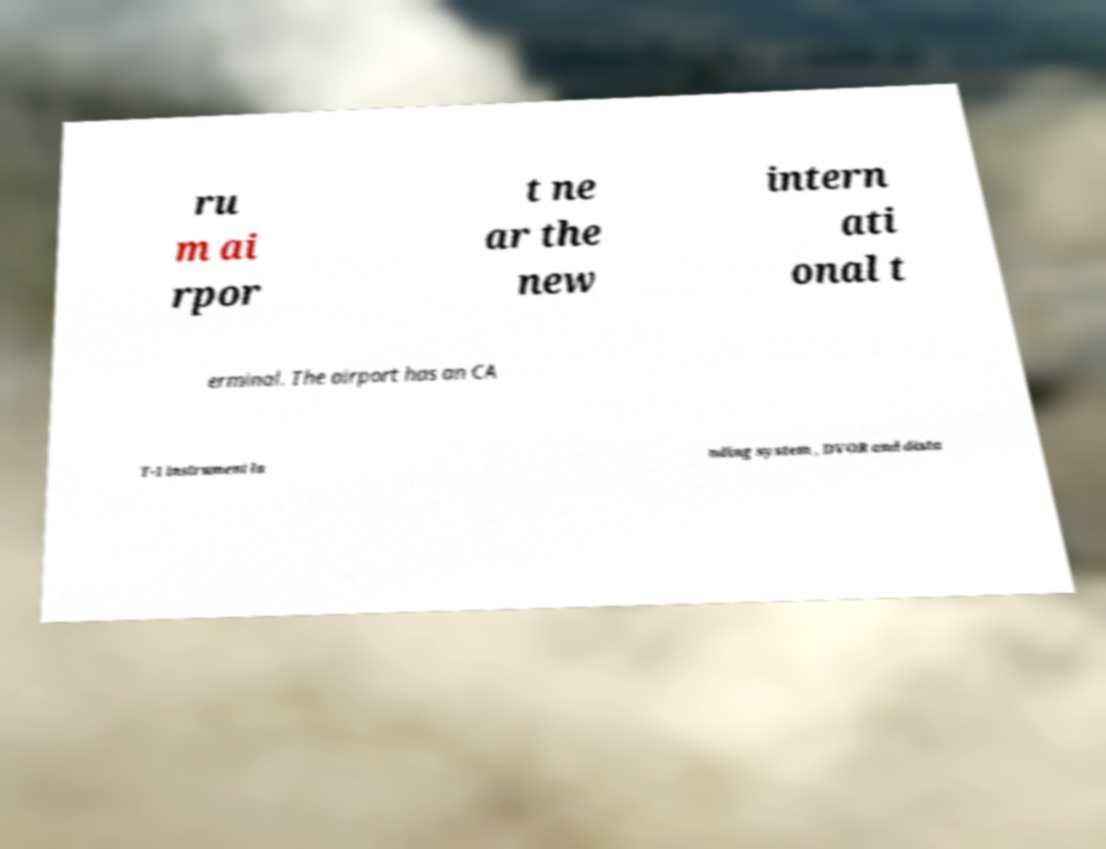Please read and relay the text visible in this image. What does it say? ru m ai rpor t ne ar the new intern ati onal t erminal. The airport has an CA T-1 instrument la nding system , DVOR and dista 